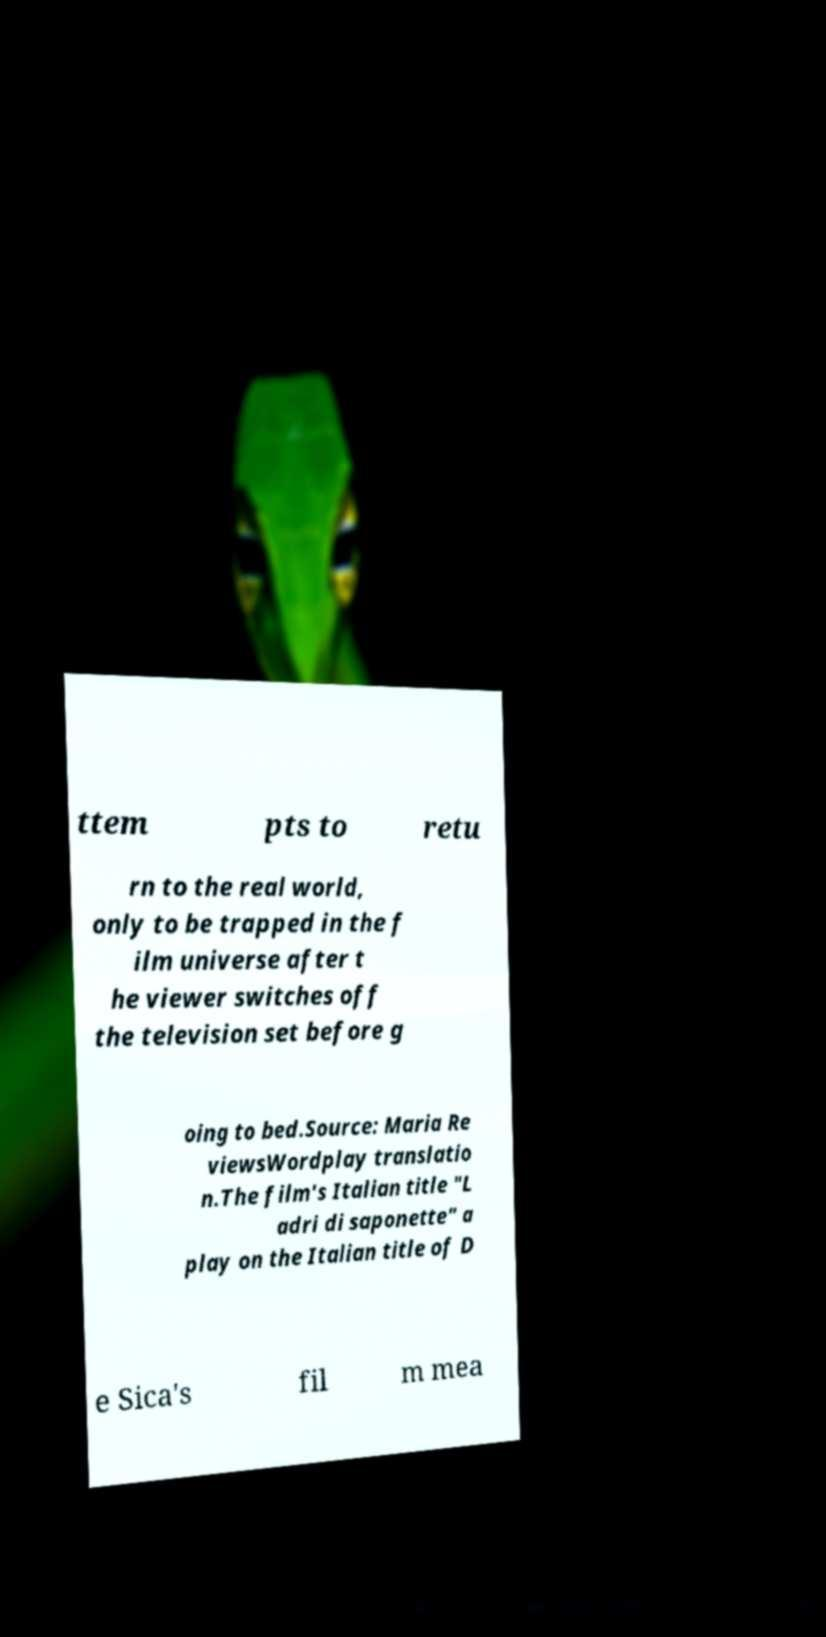I need the written content from this picture converted into text. Can you do that? ttem pts to retu rn to the real world, only to be trapped in the f ilm universe after t he viewer switches off the television set before g oing to bed.Source: Maria Re viewsWordplay translatio n.The film's Italian title "L adri di saponette" a play on the Italian title of D e Sica's fil m mea 